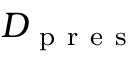<formula> <loc_0><loc_0><loc_500><loc_500>D _ { p r e s }</formula> 